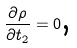<formula> <loc_0><loc_0><loc_500><loc_500>\frac { \partial \rho } { \partial t _ { 2 } } = 0 \text {,}</formula> 